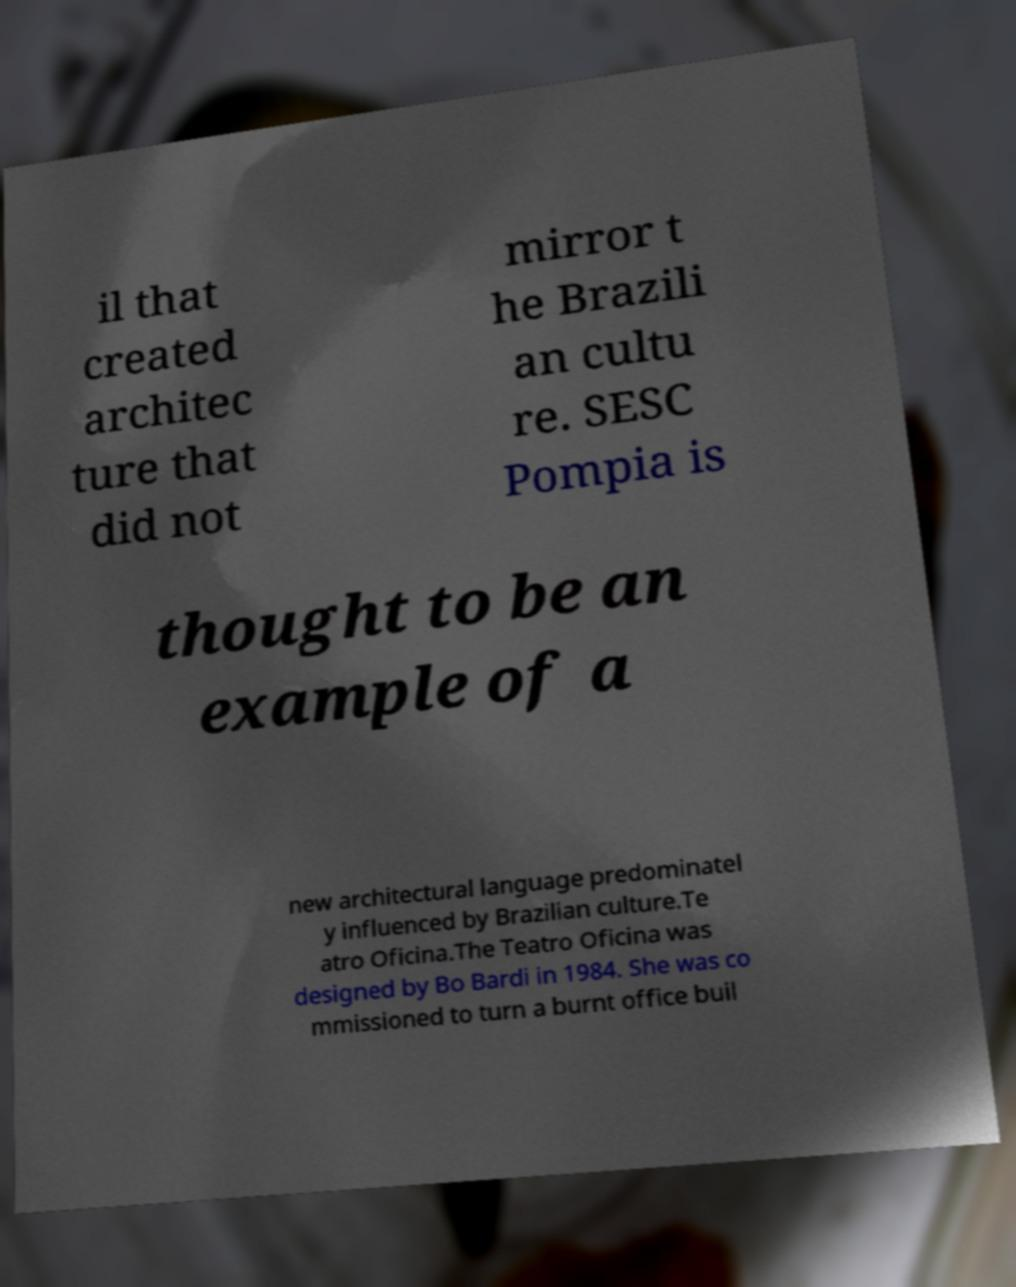Can you accurately transcribe the text from the provided image for me? il that created architec ture that did not mirror t he Brazili an cultu re. SESC Pompia is thought to be an example of a new architectural language predominatel y influenced by Brazilian culture.Te atro Oficina.The Teatro Oficina was designed by Bo Bardi in 1984. She was co mmissioned to turn a burnt office buil 